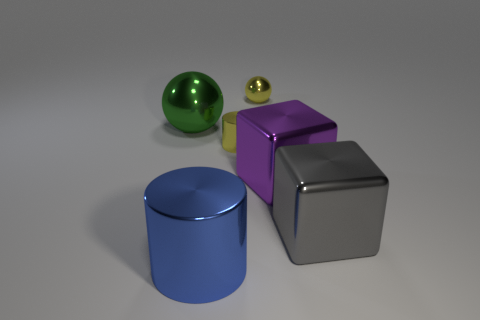What size is the metal ball on the right side of the sphere to the left of the tiny metal sphere?
Offer a very short reply. Small. What number of other things are the same shape as the gray thing?
Your answer should be compact. 1. Is the big cylinder the same color as the tiny metallic sphere?
Offer a very short reply. No. Is there anything else that is the same shape as the gray metallic thing?
Ensure brevity in your answer.  Yes. Is there a cube of the same color as the small shiny sphere?
Ensure brevity in your answer.  No. Is the large object that is behind the purple metallic cube made of the same material as the small thing behind the big green metallic object?
Offer a very short reply. Yes. The tiny cylinder has what color?
Your answer should be compact. Yellow. What size is the yellow thing to the right of the small yellow object in front of the tiny yellow thing behind the big green shiny object?
Give a very brief answer. Small. What number of other things are the same size as the green sphere?
Offer a very short reply. 3. How many brown cubes have the same material as the green sphere?
Your answer should be compact. 0. 